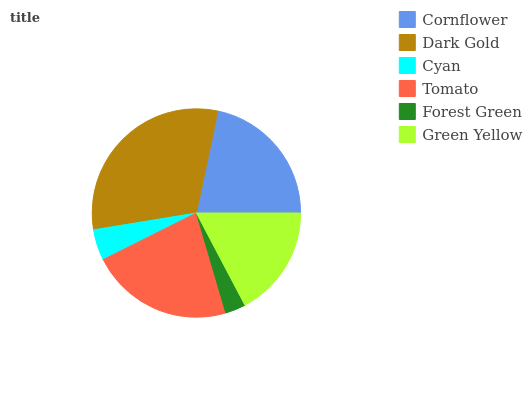Is Forest Green the minimum?
Answer yes or no. Yes. Is Dark Gold the maximum?
Answer yes or no. Yes. Is Cyan the minimum?
Answer yes or no. No. Is Cyan the maximum?
Answer yes or no. No. Is Dark Gold greater than Cyan?
Answer yes or no. Yes. Is Cyan less than Dark Gold?
Answer yes or no. Yes. Is Cyan greater than Dark Gold?
Answer yes or no. No. Is Dark Gold less than Cyan?
Answer yes or no. No. Is Cornflower the high median?
Answer yes or no. Yes. Is Green Yellow the low median?
Answer yes or no. Yes. Is Green Yellow the high median?
Answer yes or no. No. Is Dark Gold the low median?
Answer yes or no. No. 